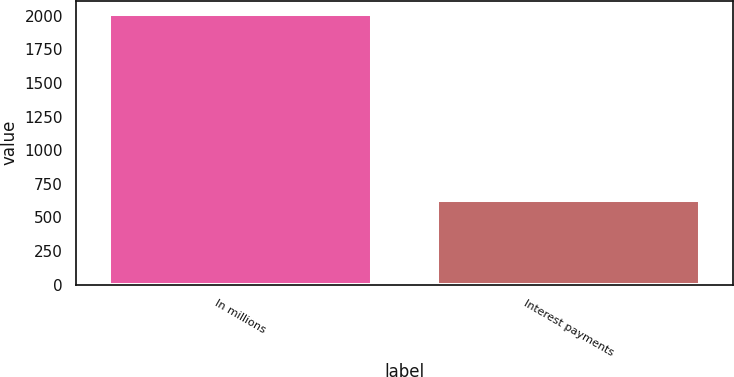<chart> <loc_0><loc_0><loc_500><loc_500><bar_chart><fcel>In millions<fcel>Interest payments<nl><fcel>2011<fcel>629<nl></chart> 